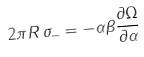Convert formula to latex. <formula><loc_0><loc_0><loc_500><loc_500>2 \pi R \, \sigma _ { - } = - \alpha \beta \frac { \partial \Omega } { \partial \alpha }</formula> 